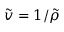<formula> <loc_0><loc_0><loc_500><loc_500>\tilde { v } = 1 / \tilde { \rho }</formula> 